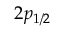Convert formula to latex. <formula><loc_0><loc_0><loc_500><loc_500>2 { p } _ { 1 / 2 }</formula> 